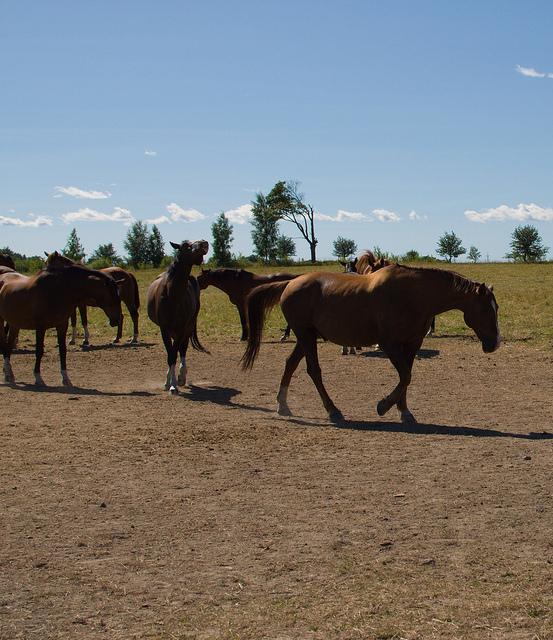Overcast or sunny?
Be succinct. Sunny. Is this an old picture?
Concise answer only. No. How many riders are mounted on these horses?
Concise answer only. 0. Are the horses the same color?
Give a very brief answer. Yes. Are these horses hungry?
Write a very short answer. Yes. Does the tree have leaves?
Answer briefly. Yes. Is the ground dry?
Give a very brief answer. Yes. Is the photo colored?
Be succinct. Yes. Are the horses moving?
Concise answer only. Yes. Are they riding side saddle?
Short answer required. No. 